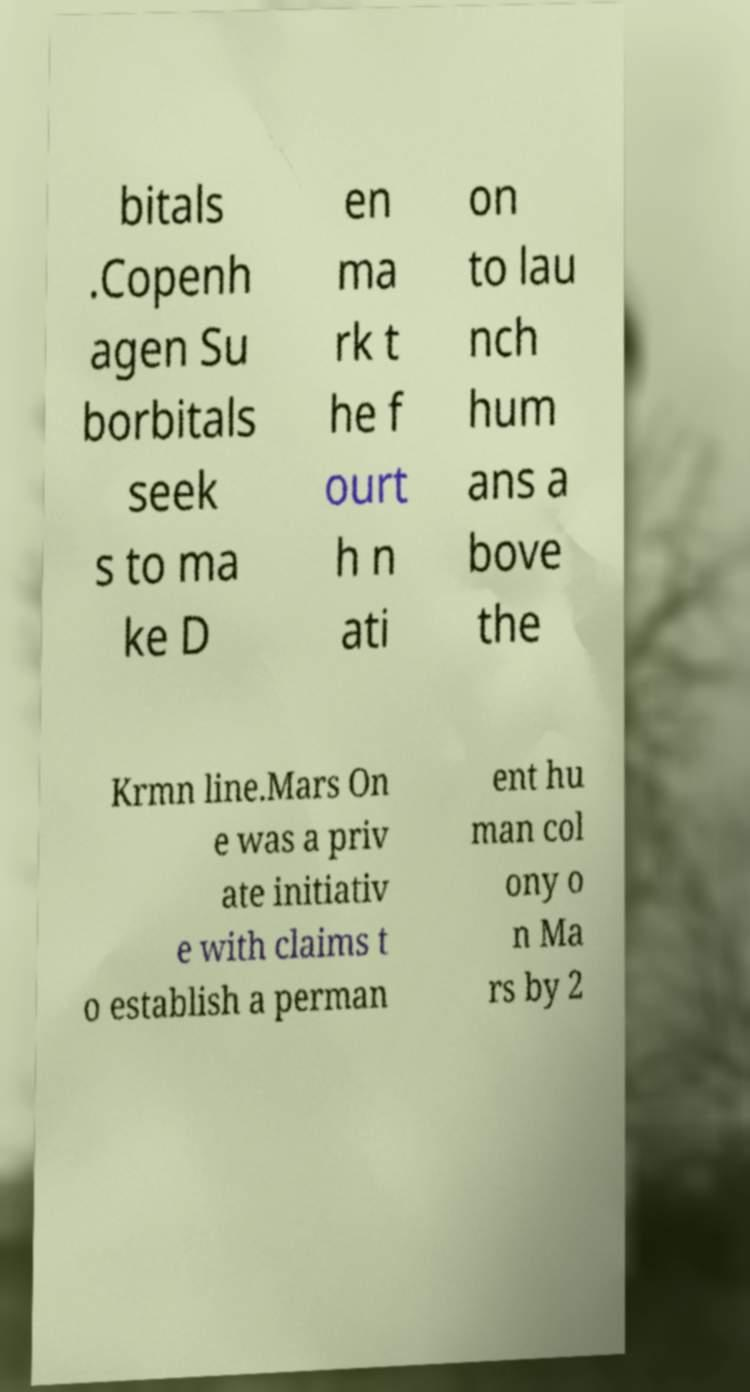Can you accurately transcribe the text from the provided image for me? bitals .Copenh agen Su borbitals seek s to ma ke D en ma rk t he f ourt h n ati on to lau nch hum ans a bove the Krmn line.Mars On e was a priv ate initiativ e with claims t o establish a perman ent hu man col ony o n Ma rs by 2 